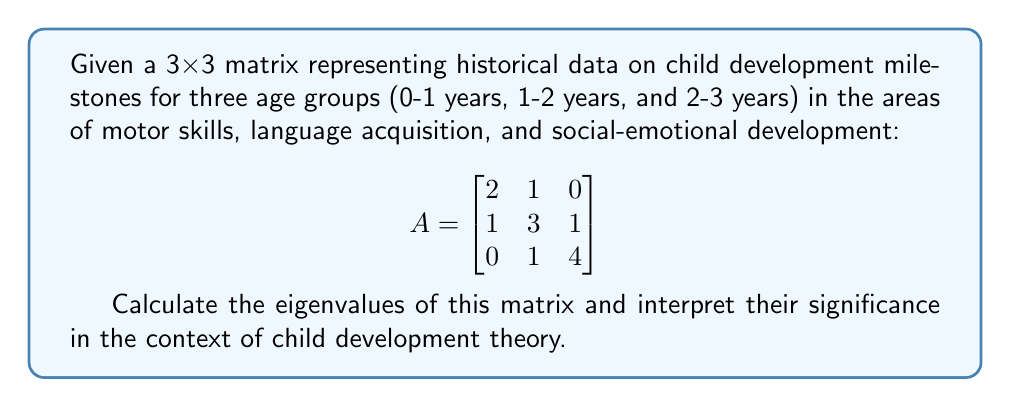Can you answer this question? To find the eigenvalues of matrix A, we need to solve the characteristic equation:

1) First, we set up the equation $det(A - \lambda I) = 0$, where $I$ is the 3x3 identity matrix:

   $$det\begin{pmatrix}
   2-\lambda & 1 & 0 \\
   1 & 3-\lambda & 1 \\
   0 & 1 & 4-\lambda
   \end{pmatrix} = 0$$

2) Expanding the determinant:
   $$(2-\lambda)[(3-\lambda)(4-\lambda) - 1] - 1[1(4-\lambda) - 0] + 0 = 0$$

3) Simplifying:
   $$(2-\lambda)[(12-7\lambda+\lambda^2) - 1] - (4-\lambda) = 0$$
   $$(2-\lambda)(11-7\lambda+\lambda^2) - 4 + \lambda = 0$$

4) Expanding:
   $$22-14\lambda+2\lambda^2-11\lambda+7\lambda^2-\lambda^3-4+\lambda = 0$$

5) Collecting terms:
   $$-\lambda^3 + 9\lambda^2 - 24\lambda + 18 = 0$$

6) This is a cubic equation. Using the cubic formula or a computer algebra system, we find the roots:

   $\lambda_1 = 2$
   $\lambda_2 = 3$
   $\lambda_3 = 4$

Interpretation: In the context of child development theory, these eigenvalues represent the principal components or key factors influencing development across the three domains (motor, language, social-emotional) for the given age groups. The largest eigenvalue (4) suggests a dominant trend, possibly indicating a critical period of rapid development in one area. The other two eigenvalues (3 and 2) represent secondary and tertiary factors, which may correspond to areas of slower but still significant growth.
Answer: Eigenvalues: 2, 3, and 4 